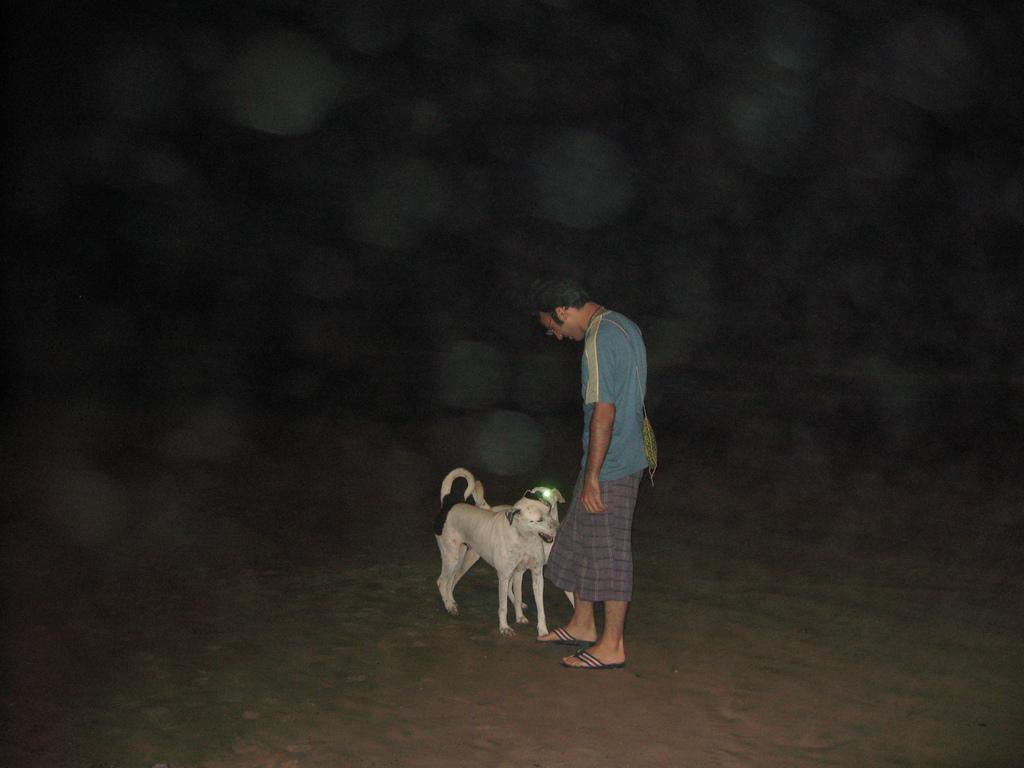Who is present in the image? There is a man in the image. What is the lighting condition in the image? The man is standing in the dark. Are there any animals in the image? Yes, there are two dogs in the image. What are the dogs doing in the image? The dogs are standing along with the man. What is the man wearing in the image? The man is wearing shorts and a blue shirt. How many waves can be seen in the image? There are no waves present in the image. What type of zebra is standing next to the man in the image? There is no zebra present in the image. 